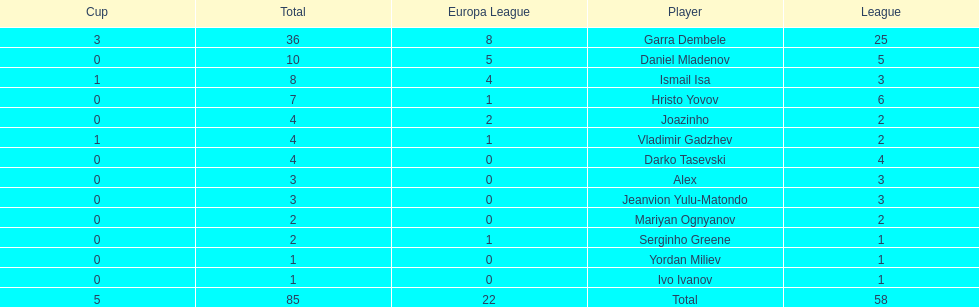How many of the players did not score any goals in the cup? 10. 